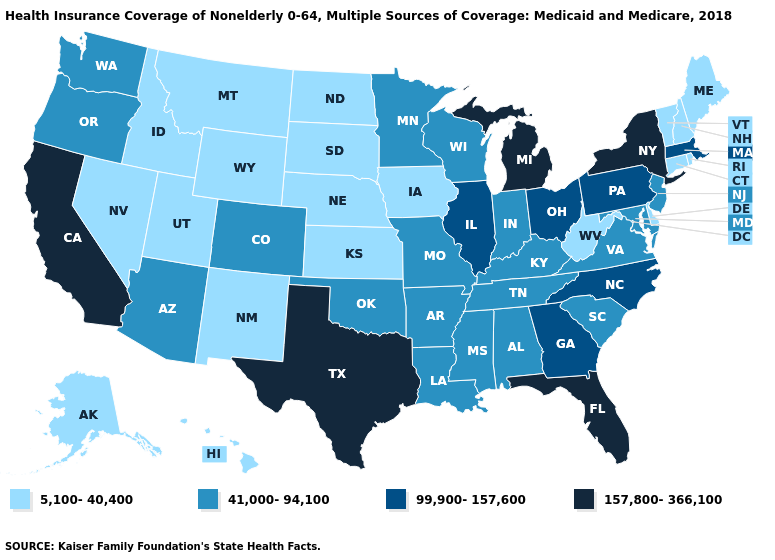Name the states that have a value in the range 41,000-94,100?
Short answer required. Alabama, Arizona, Arkansas, Colorado, Indiana, Kentucky, Louisiana, Maryland, Minnesota, Mississippi, Missouri, New Jersey, Oklahoma, Oregon, South Carolina, Tennessee, Virginia, Washington, Wisconsin. Among the states that border Tennessee , which have the lowest value?
Quick response, please. Alabama, Arkansas, Kentucky, Mississippi, Missouri, Virginia. What is the value of South Carolina?
Short answer required. 41,000-94,100. Which states have the lowest value in the USA?
Be succinct. Alaska, Connecticut, Delaware, Hawaii, Idaho, Iowa, Kansas, Maine, Montana, Nebraska, Nevada, New Hampshire, New Mexico, North Dakota, Rhode Island, South Dakota, Utah, Vermont, West Virginia, Wyoming. Among the states that border Idaho , which have the lowest value?
Quick response, please. Montana, Nevada, Utah, Wyoming. Name the states that have a value in the range 99,900-157,600?
Be succinct. Georgia, Illinois, Massachusetts, North Carolina, Ohio, Pennsylvania. Name the states that have a value in the range 41,000-94,100?
Write a very short answer. Alabama, Arizona, Arkansas, Colorado, Indiana, Kentucky, Louisiana, Maryland, Minnesota, Mississippi, Missouri, New Jersey, Oklahoma, Oregon, South Carolina, Tennessee, Virginia, Washington, Wisconsin. Does New Mexico have the lowest value in the USA?
Give a very brief answer. Yes. What is the value of Illinois?
Give a very brief answer. 99,900-157,600. Is the legend a continuous bar?
Short answer required. No. How many symbols are there in the legend?
Give a very brief answer. 4. Which states have the highest value in the USA?
Concise answer only. California, Florida, Michigan, New York, Texas. Name the states that have a value in the range 5,100-40,400?
Quick response, please. Alaska, Connecticut, Delaware, Hawaii, Idaho, Iowa, Kansas, Maine, Montana, Nebraska, Nevada, New Hampshire, New Mexico, North Dakota, Rhode Island, South Dakota, Utah, Vermont, West Virginia, Wyoming. Does South Dakota have the lowest value in the USA?
Keep it brief. Yes. Name the states that have a value in the range 157,800-366,100?
Give a very brief answer. California, Florida, Michigan, New York, Texas. 